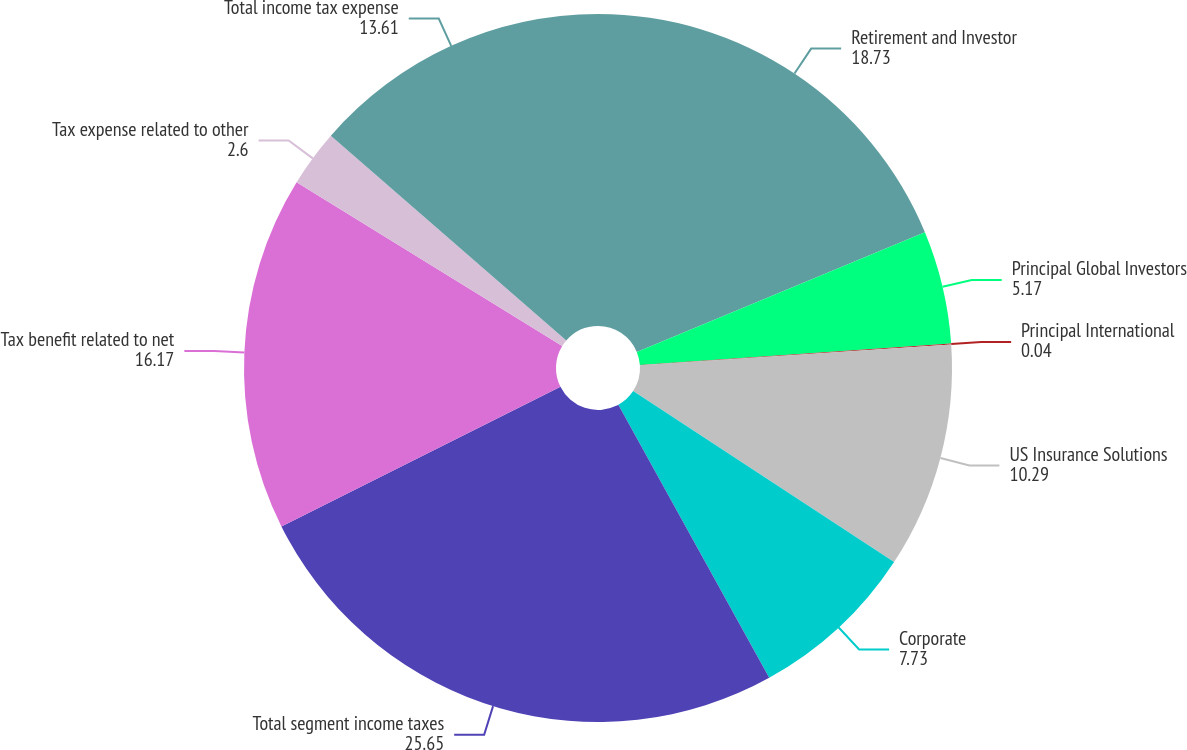Convert chart to OTSL. <chart><loc_0><loc_0><loc_500><loc_500><pie_chart><fcel>Retirement and Investor<fcel>Principal Global Investors<fcel>Principal International<fcel>US Insurance Solutions<fcel>Corporate<fcel>Total segment income taxes<fcel>Tax benefit related to net<fcel>Tax expense related to other<fcel>Total income tax expense<nl><fcel>18.73%<fcel>5.17%<fcel>0.04%<fcel>10.29%<fcel>7.73%<fcel>25.65%<fcel>16.17%<fcel>2.6%<fcel>13.61%<nl></chart> 